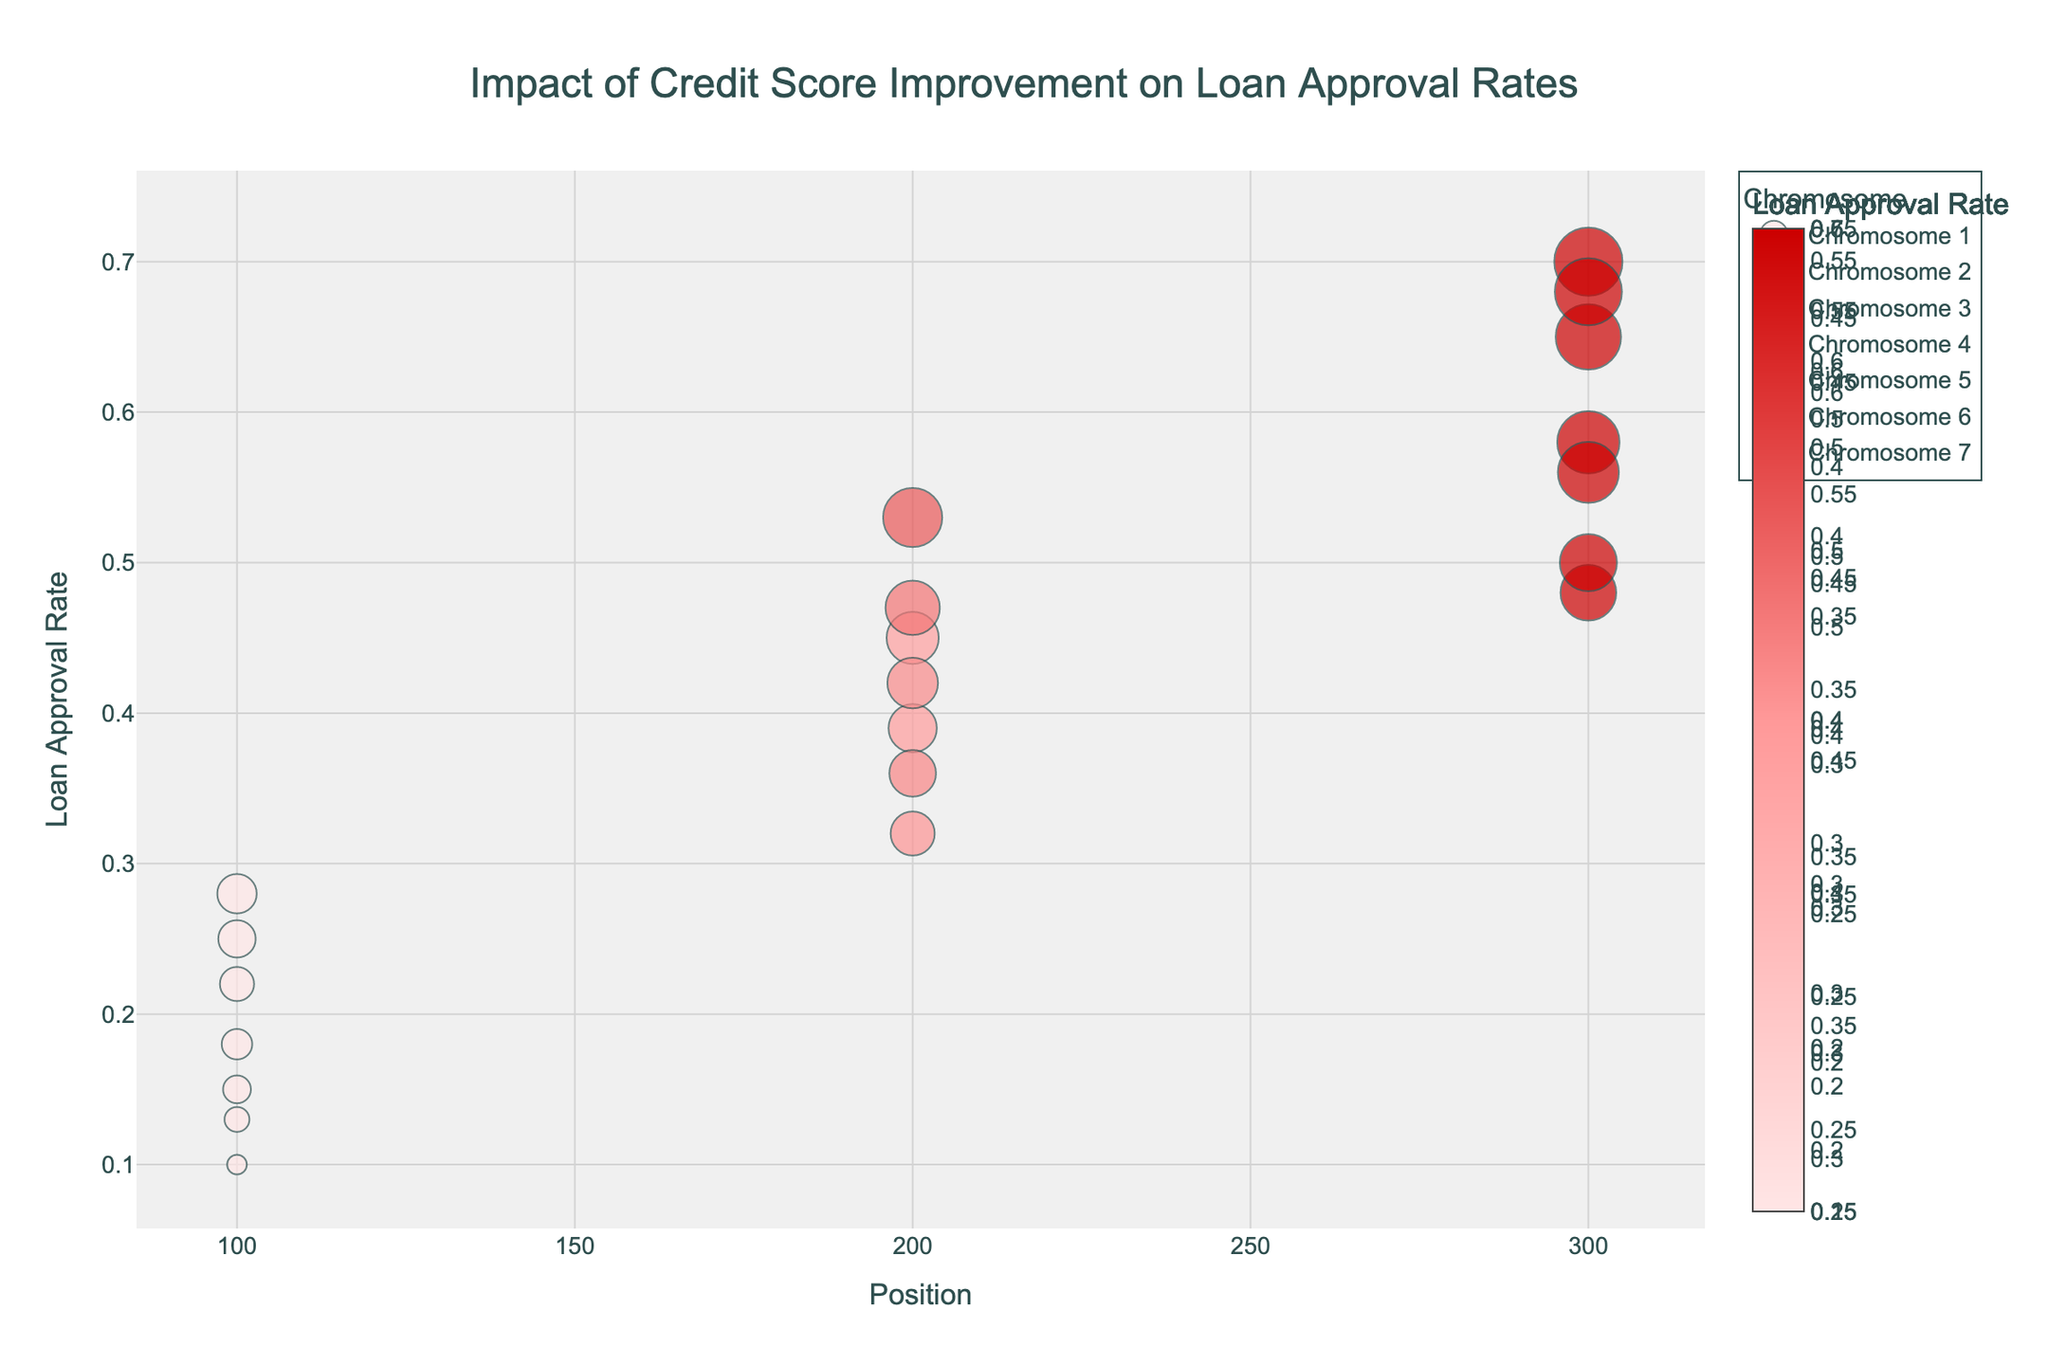What's the main title of the plot? The title is usually displayed at the top of the plot. By looking at the rendered image, you can easily read the title text.
Answer: Impact of Credit Score Improvement on Loan Approval Rates Which chromosome has the highest loan approval rate? To find the chromosome with the highest loan approval rate, you need to look at the highest points on the y-axis and identify the corresponding chromosome.
Answer: Chromosome 4 What is the loan approval rate at position 200 on Chromosome 5? Examine the point that corresponds to position 200 on the x-axis for Chromosome 5 and read the corresponding y-value.
Answer: 0.36 Compare the loan approval rates at positions 100 and 300 on Chromosome 3. Which is higher? To compare the rates, find the points at positions 100 and 300 on Chromosome 3, and compare their y-values. Position 300 has a loan approval rate of 0.65 while position 100 has a rate of 0.28, hence 0.65 is higher.
Answer: 0.65 is higher What is the average loan approval rate for Chromosome 2? Compute the average by adding the loan approval rates for Chromosome 2 and then dividing by the number of data points. The rates are 0.22, 0.39, and 0.58, so the average is (0.22 + 0.39 + 0.58) / 3.
Answer: 0.397 Which chromosome shows a notable increase in loan approval rate when comparing the lowest and highest positions? Look for a chromosome where the difference between the lowest and highest points on the y-axis is the largest. Chromosome 4 shows an increase from 0.10 to 0.70.
Answer: Chromosome 4 At what position on Chromosome 7 does the loan approval rate peak? Identify the highest point on Chromosome 7's plot and find its corresponding position on the x-axis.
Answer: Position 300 How many chromosomes have loan approval rates that go above 0.50 at any position? Count the chromosomes with at least one point above the 0.50 mark on the y-axis. Chromosomes 3, 4, and 7 meet this criterion.
Answer: 3 chromosomes What is the difference in loan approval rates between positions 100 and 200 on Chromosome 1? Subtract the loan approval rate at position 100 from the rate at position 200 for Chromosome 1. The rates are 0.15 and 0.32, respectively, so the difference is 0.32 - 0.15.
Answer: 0.17 